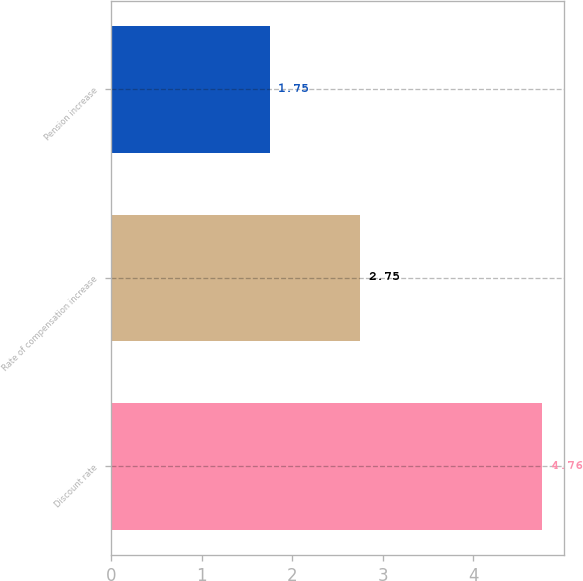<chart> <loc_0><loc_0><loc_500><loc_500><bar_chart><fcel>Discount rate<fcel>Rate of compensation increase<fcel>Pension increase<nl><fcel>4.76<fcel>2.75<fcel>1.75<nl></chart> 